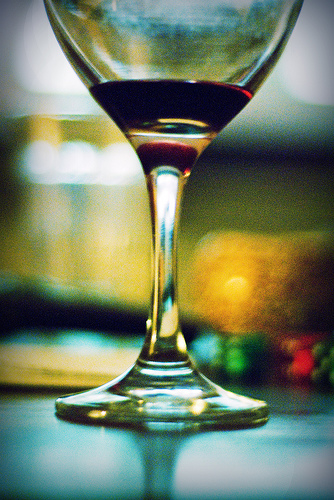<image>
Is the wine on the table? Yes. Looking at the image, I can see the wine is positioned on top of the table, with the table providing support. 